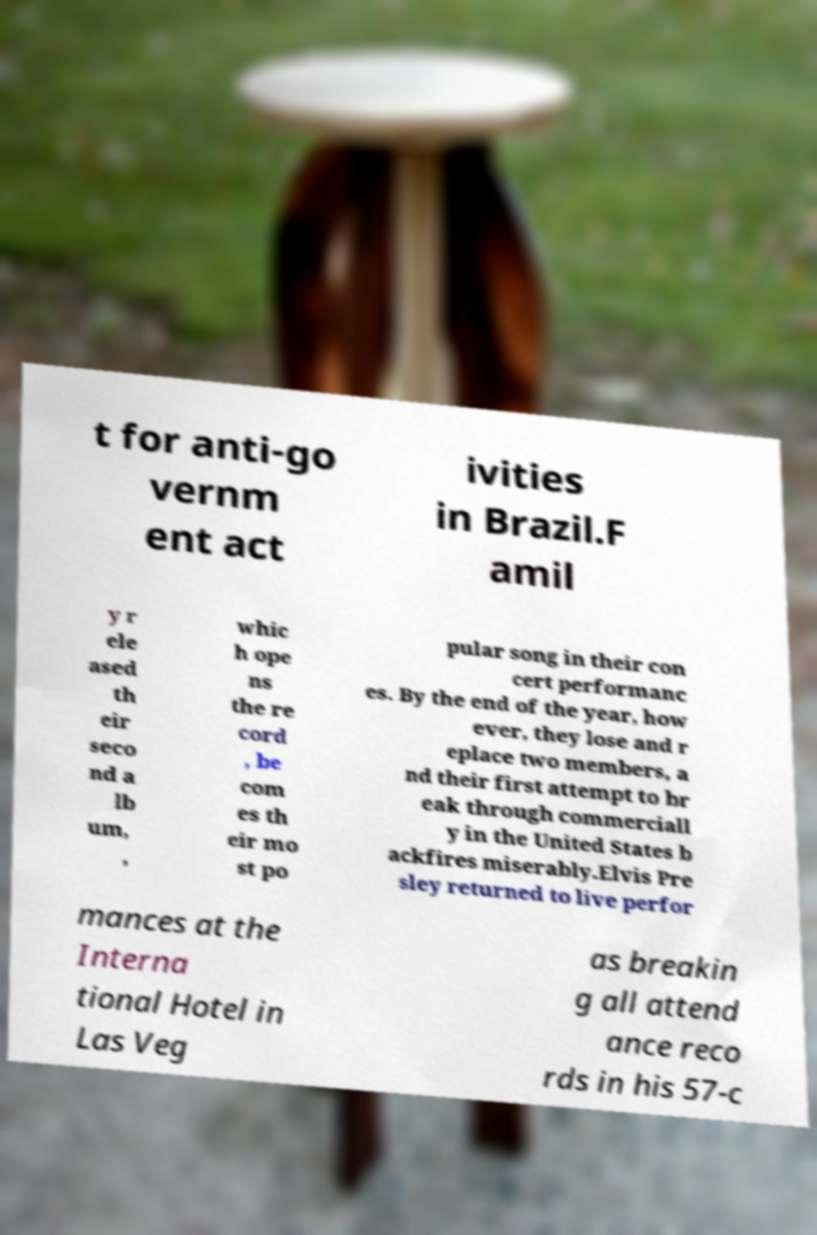What messages or text are displayed in this image? I need them in a readable, typed format. t for anti-go vernm ent act ivities in Brazil.F amil y r ele ased th eir seco nd a lb um, , whic h ope ns the re cord , be com es th eir mo st po pular song in their con cert performanc es. By the end of the year, how ever, they lose and r eplace two members, a nd their first attempt to br eak through commerciall y in the United States b ackfires miserably.Elvis Pre sley returned to live perfor mances at the Interna tional Hotel in Las Veg as breakin g all attend ance reco rds in his 57-c 